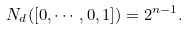Convert formula to latex. <formula><loc_0><loc_0><loc_500><loc_500>N _ { d } ( [ 0 , \cdots , 0 , 1 ] ) = 2 ^ { n - 1 } .</formula> 